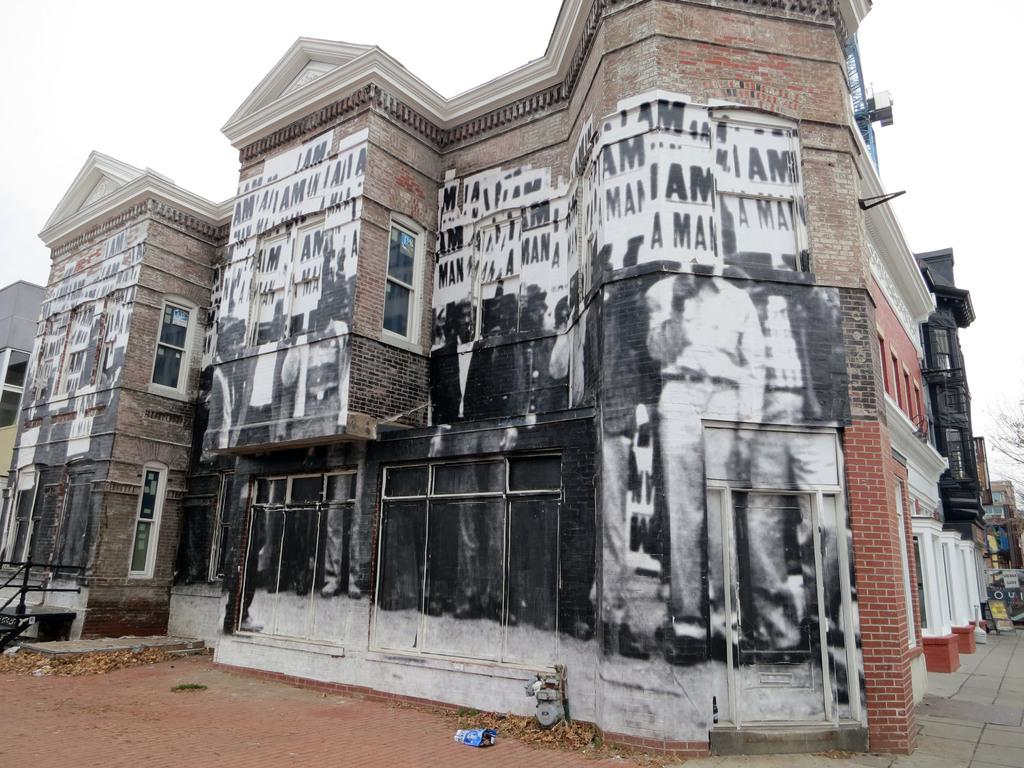What type of structures can be seen in the image? There are buildings in the image. What material is used for the rods in the image? Metal rods are present in the image. Where is the tree located in the image? There is a tree on the right side of the image. What type of artwork is visible on the walls in the image? Paintings are visible on the walls. How many dogs are shown expressing disgust in the image? There are no dogs present in the image, and therefore no such expression of disgust can be observed. 